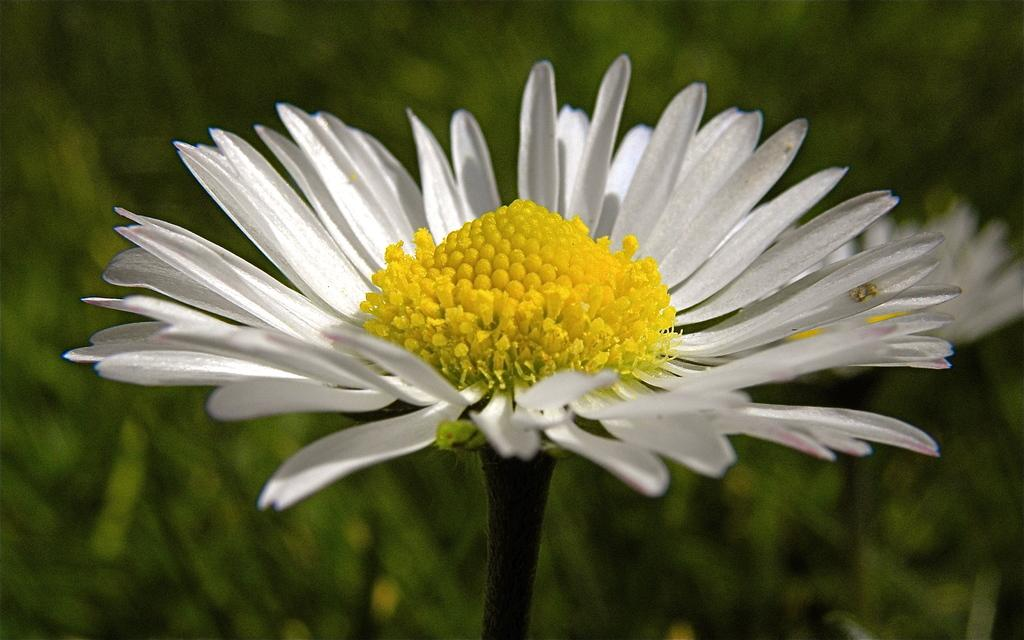What is the main subject of the image? There is a flower in the image. Can you describe the colors of the flower? The flower has yellow and white colors. How would you describe the background of the image? The background of the image is blurred. What color is the background? The background color is green. What type of fiction is the flower reading in the image? There is no indication in the image that the flower is reading any fiction, as flowers do not have the ability to read. 